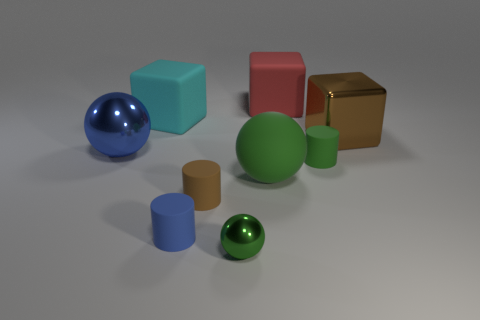Is the number of cyan matte blocks that are to the left of the cyan cube the same as the number of big metal objects?
Ensure brevity in your answer.  No. There is a matte object that is in front of the big red block and behind the large brown block; what is its size?
Make the answer very short. Large. The large object in front of the cylinder to the right of the tiny shiny thing is what color?
Ensure brevity in your answer.  Green. What number of blue things are tiny cylinders or small balls?
Your response must be concise. 1. There is a thing that is in front of the brown metallic thing and behind the green rubber cylinder; what is its color?
Make the answer very short. Blue. What number of tiny objects are yellow rubber things or green rubber things?
Keep it short and to the point. 1. What size is the cyan object that is the same shape as the large brown object?
Offer a very short reply. Large. What is the shape of the blue rubber thing?
Provide a short and direct response. Cylinder. Do the large green thing and the big object to the right of the red cube have the same material?
Provide a succinct answer. No. How many matte things are big cyan blocks or big blue cylinders?
Provide a short and direct response. 1. 